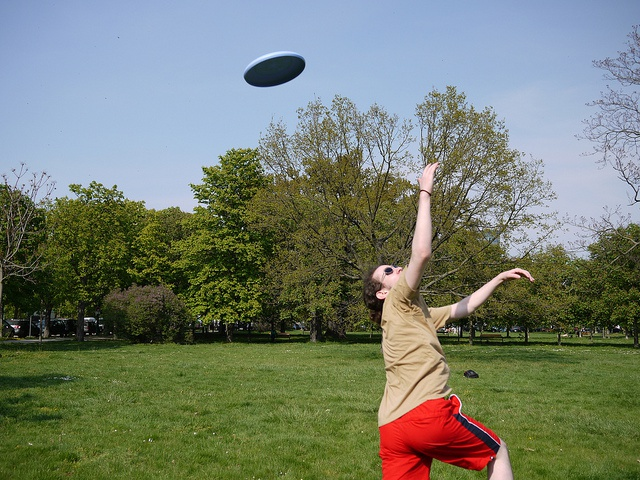Describe the objects in this image and their specific colors. I can see people in gray, red, tan, and pink tones and frisbee in gray, black, navy, and lightblue tones in this image. 